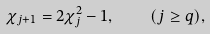Convert formula to latex. <formula><loc_0><loc_0><loc_500><loc_500>\chi _ { j + 1 } = 2 \chi _ { j } ^ { 2 } - 1 , \quad ( j \geq q ) ,</formula> 